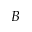Convert formula to latex. <formula><loc_0><loc_0><loc_500><loc_500>B</formula> 